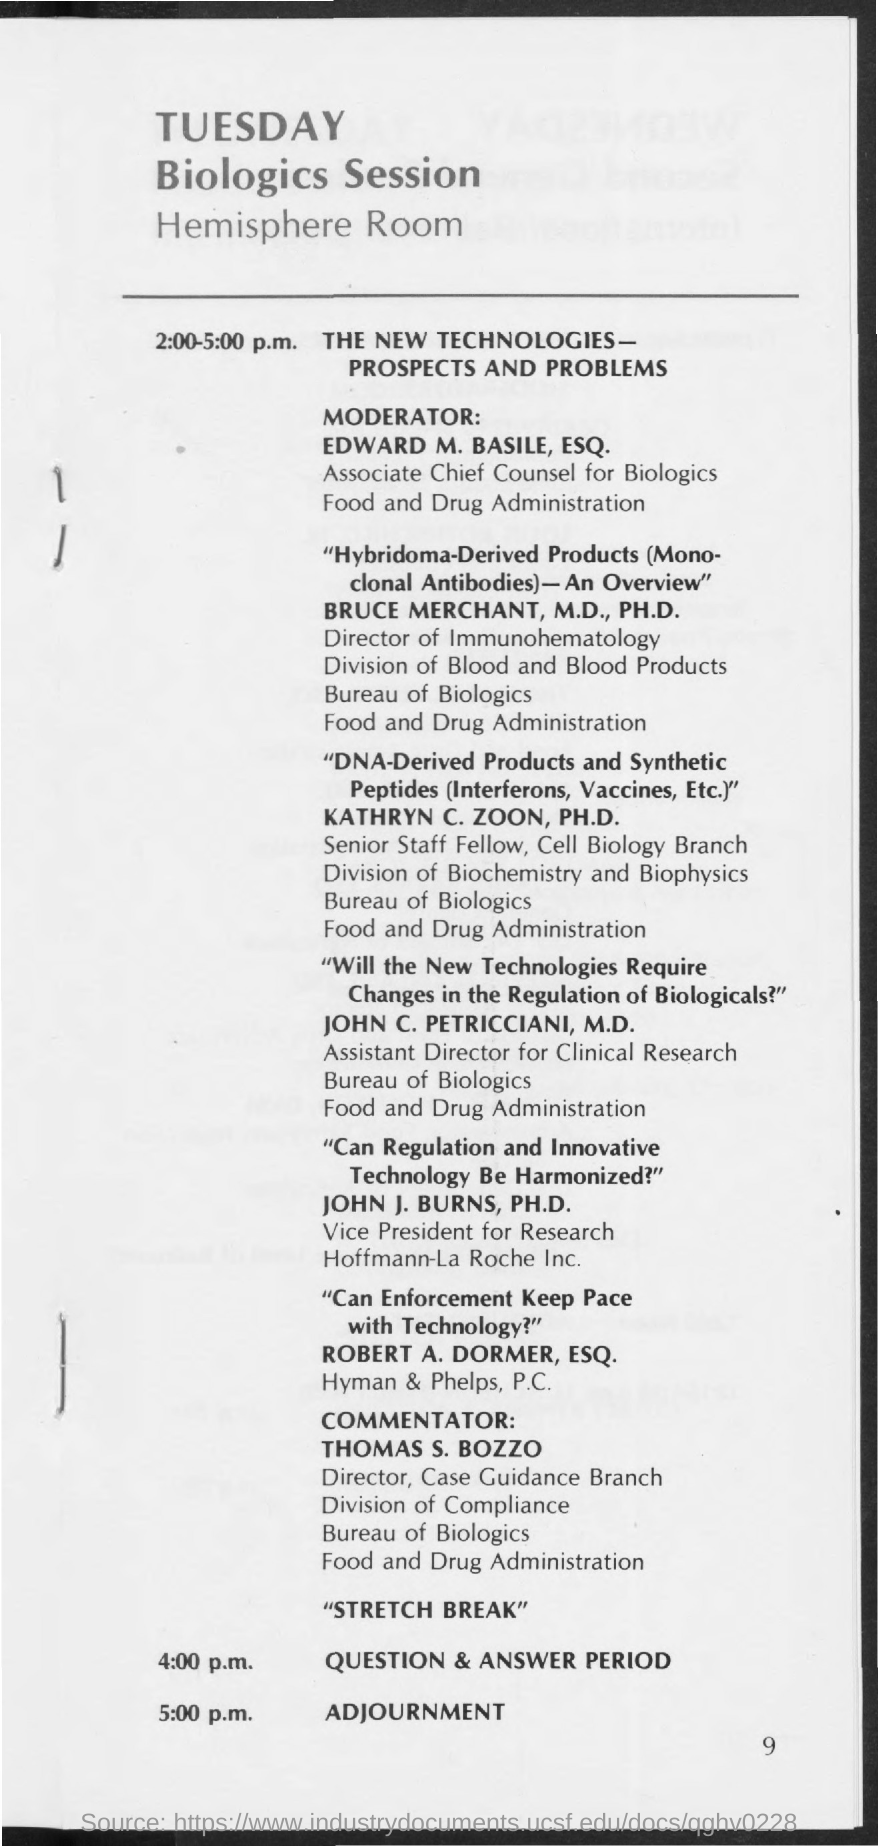When is adjourment?
Provide a short and direct response. 5:00 p.m. 